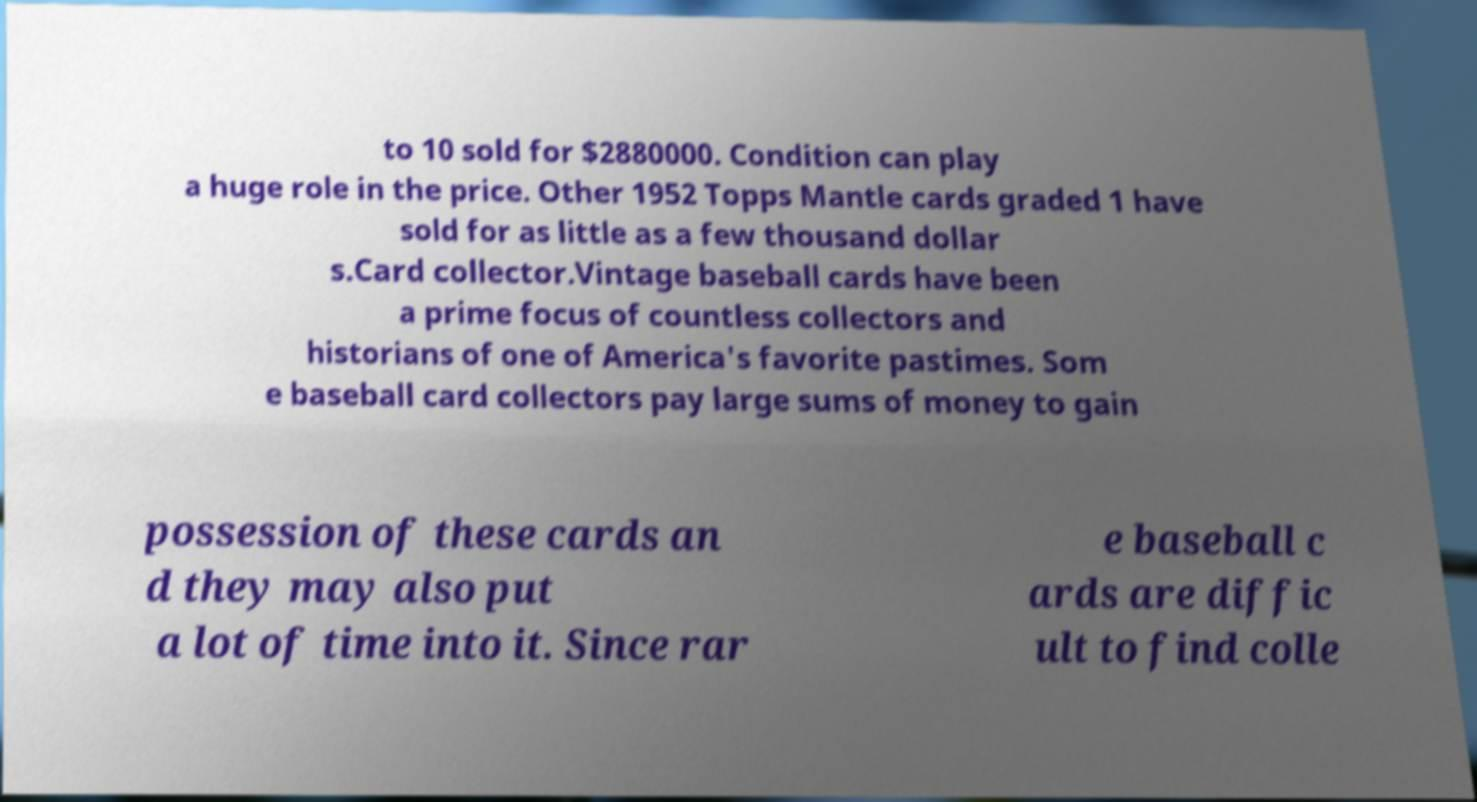Can you read and provide the text displayed in the image?This photo seems to have some interesting text. Can you extract and type it out for me? to 10 sold for $2880000. Condition can play a huge role in the price. Other 1952 Topps Mantle cards graded 1 have sold for as little as a few thousand dollar s.Card collector.Vintage baseball cards have been a prime focus of countless collectors and historians of one of America's favorite pastimes. Som e baseball card collectors pay large sums of money to gain possession of these cards an d they may also put a lot of time into it. Since rar e baseball c ards are diffic ult to find colle 